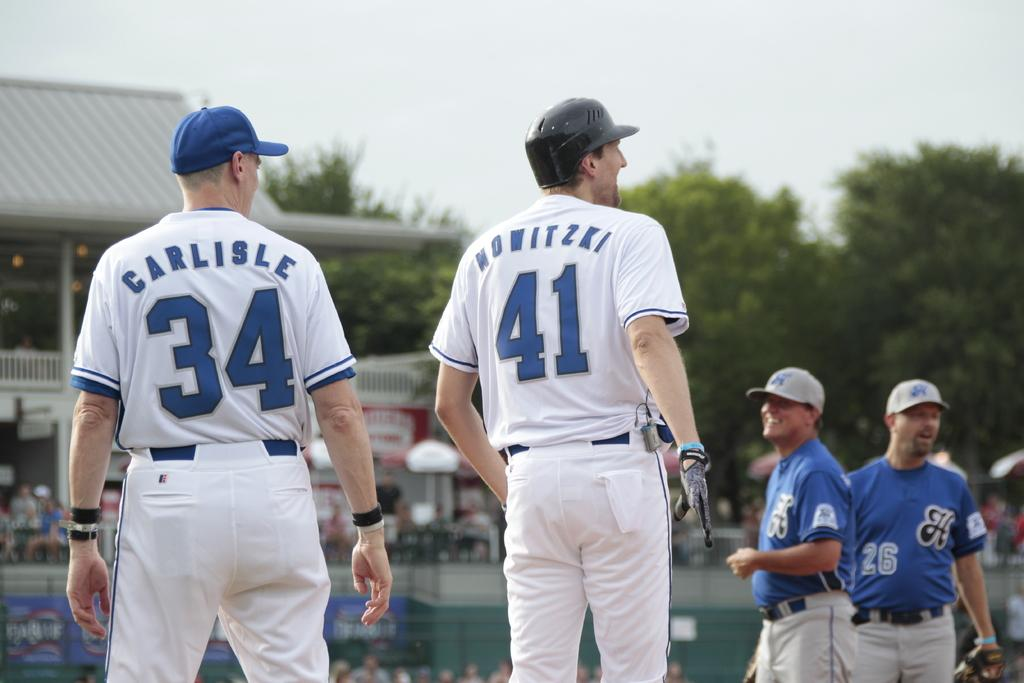<image>
Summarize the visual content of the image. a man with the number 41 on his jersey 